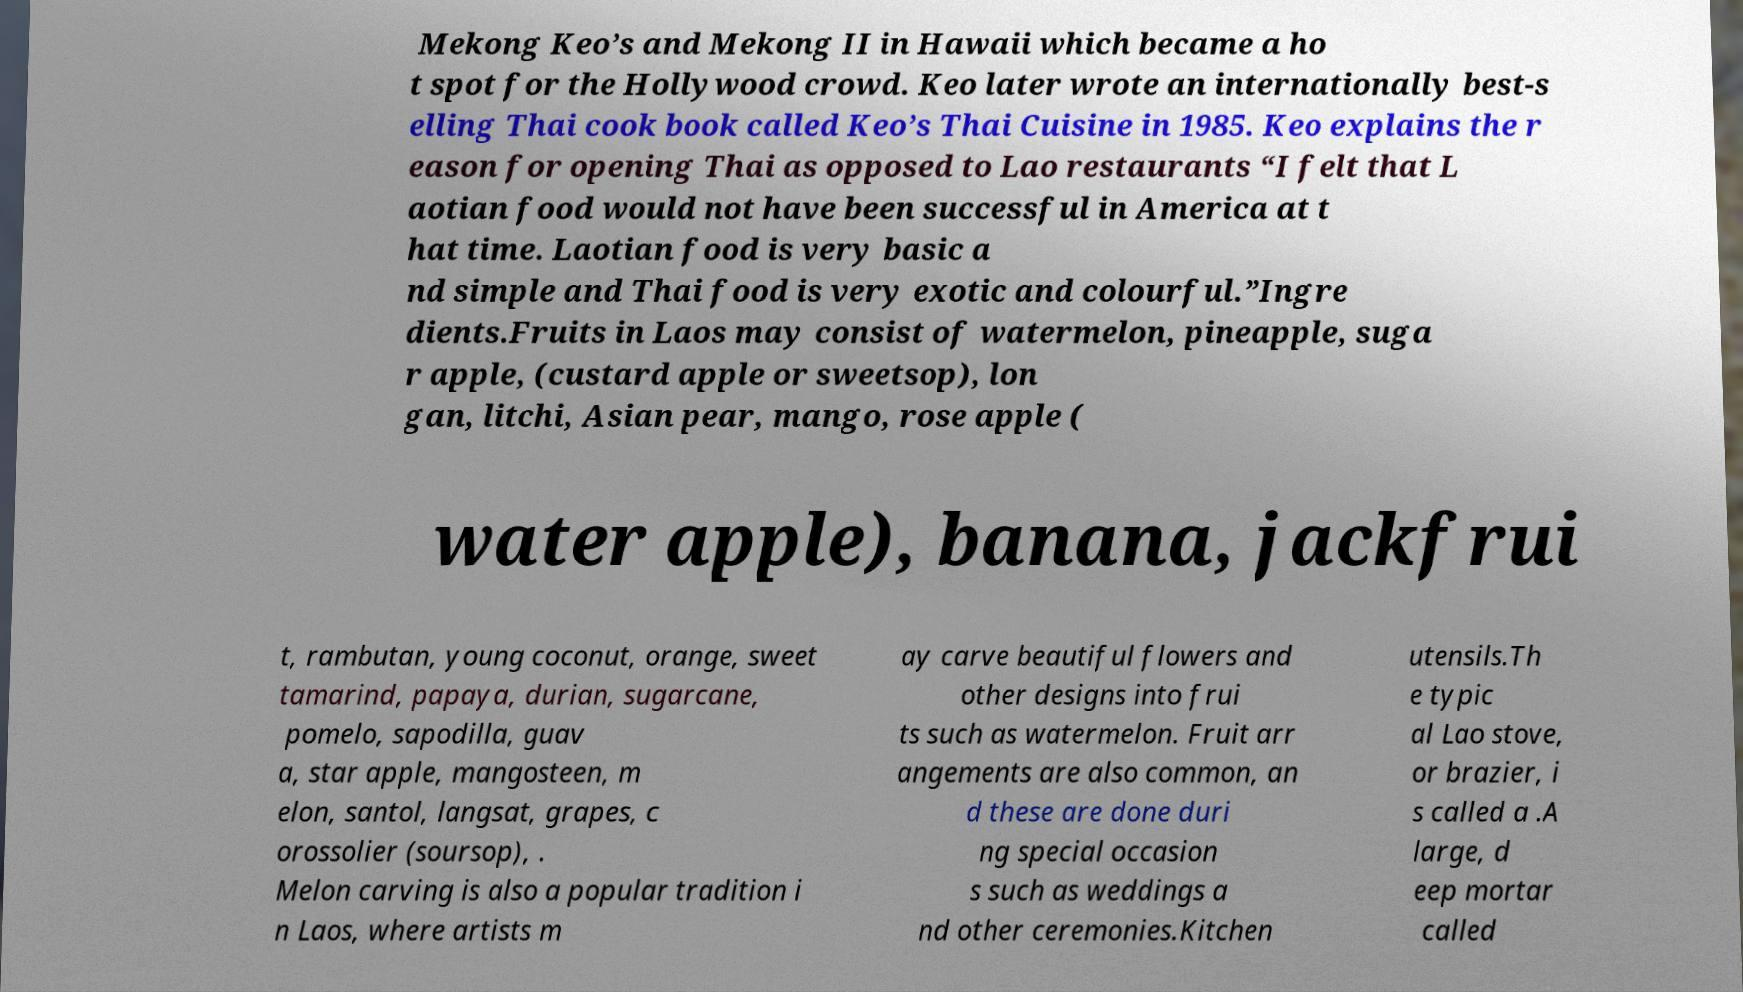Could you assist in decoding the text presented in this image and type it out clearly? Mekong Keo’s and Mekong II in Hawaii which became a ho t spot for the Hollywood crowd. Keo later wrote an internationally best-s elling Thai cook book called Keo’s Thai Cuisine in 1985. Keo explains the r eason for opening Thai as opposed to Lao restaurants “I felt that L aotian food would not have been successful in America at t hat time. Laotian food is very basic a nd simple and Thai food is very exotic and colourful.”Ingre dients.Fruits in Laos may consist of watermelon, pineapple, suga r apple, (custard apple or sweetsop), lon gan, litchi, Asian pear, mango, rose apple ( water apple), banana, jackfrui t, rambutan, young coconut, orange, sweet tamarind, papaya, durian, sugarcane, pomelo, sapodilla, guav a, star apple, mangosteen, m elon, santol, langsat, grapes, c orossolier (soursop), . Melon carving is also a popular tradition i n Laos, where artists m ay carve beautiful flowers and other designs into frui ts such as watermelon. Fruit arr angements are also common, an d these are done duri ng special occasion s such as weddings a nd other ceremonies.Kitchen utensils.Th e typic al Lao stove, or brazier, i s called a .A large, d eep mortar called 